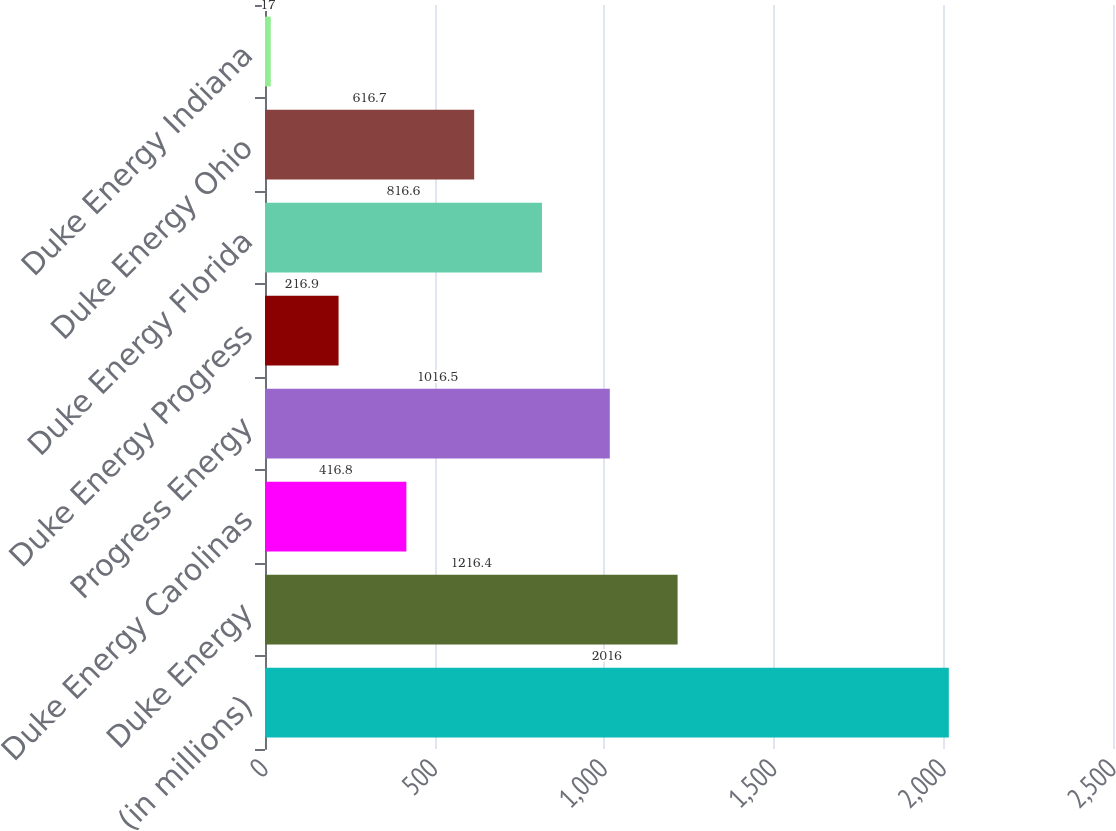<chart> <loc_0><loc_0><loc_500><loc_500><bar_chart><fcel>(in millions)<fcel>Duke Energy<fcel>Duke Energy Carolinas<fcel>Progress Energy<fcel>Duke Energy Progress<fcel>Duke Energy Florida<fcel>Duke Energy Ohio<fcel>Duke Energy Indiana<nl><fcel>2016<fcel>1216.4<fcel>416.8<fcel>1016.5<fcel>216.9<fcel>816.6<fcel>616.7<fcel>17<nl></chart> 